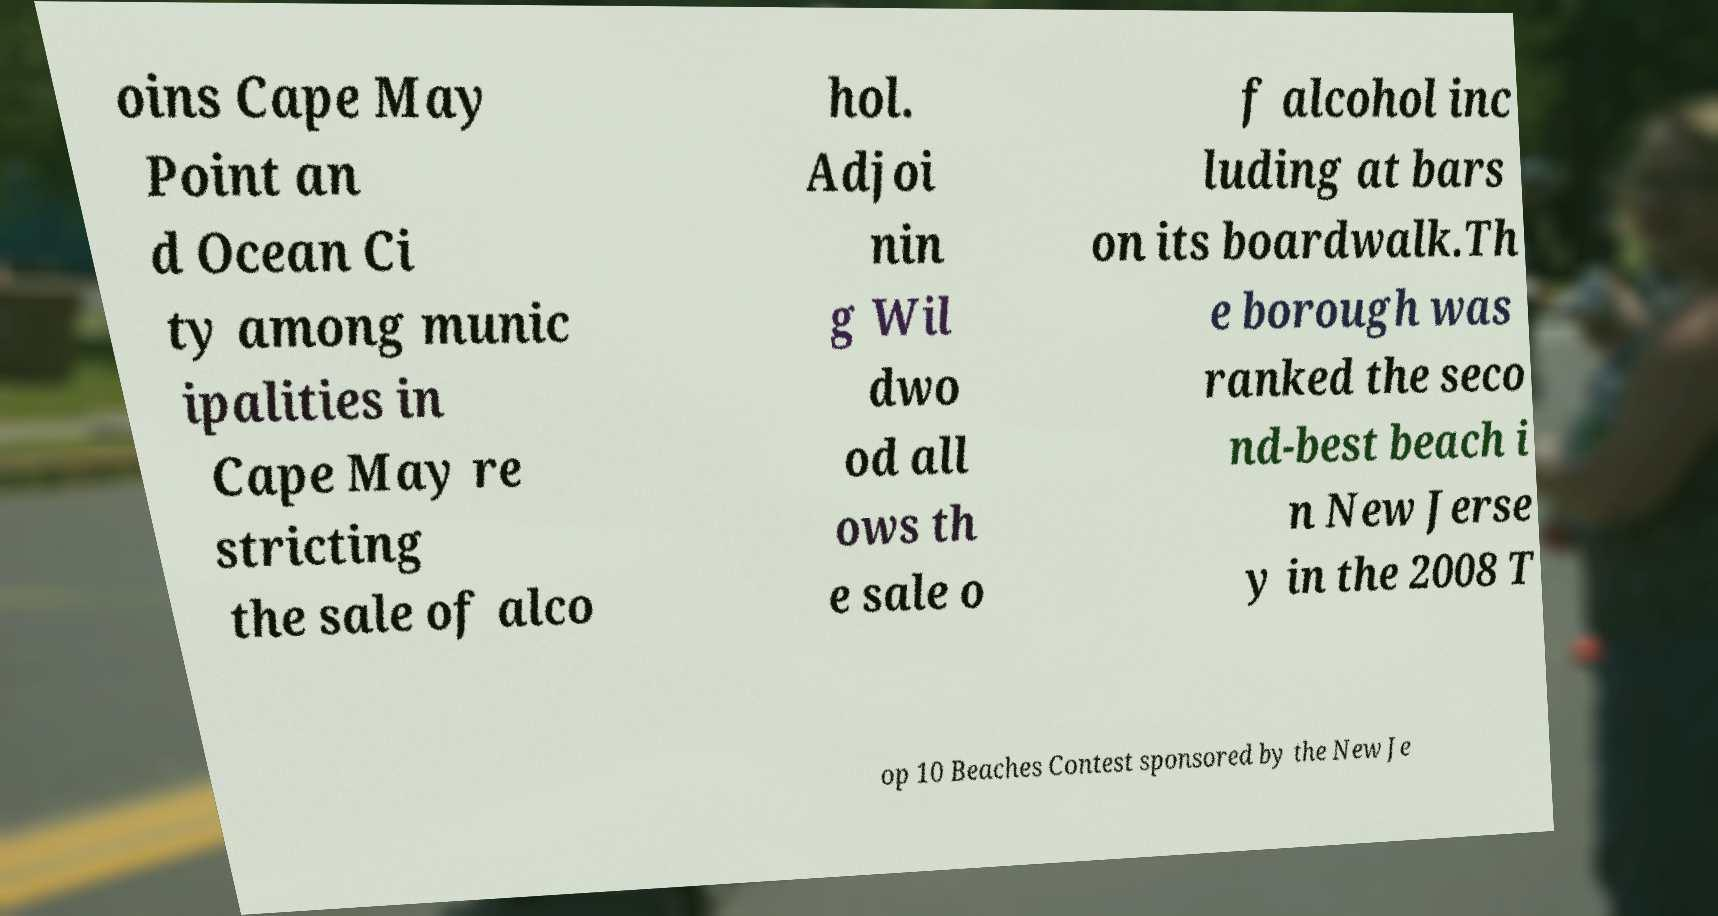I need the written content from this picture converted into text. Can you do that? oins Cape May Point an d Ocean Ci ty among munic ipalities in Cape May re stricting the sale of alco hol. Adjoi nin g Wil dwo od all ows th e sale o f alcohol inc luding at bars on its boardwalk.Th e borough was ranked the seco nd-best beach i n New Jerse y in the 2008 T op 10 Beaches Contest sponsored by the New Je 